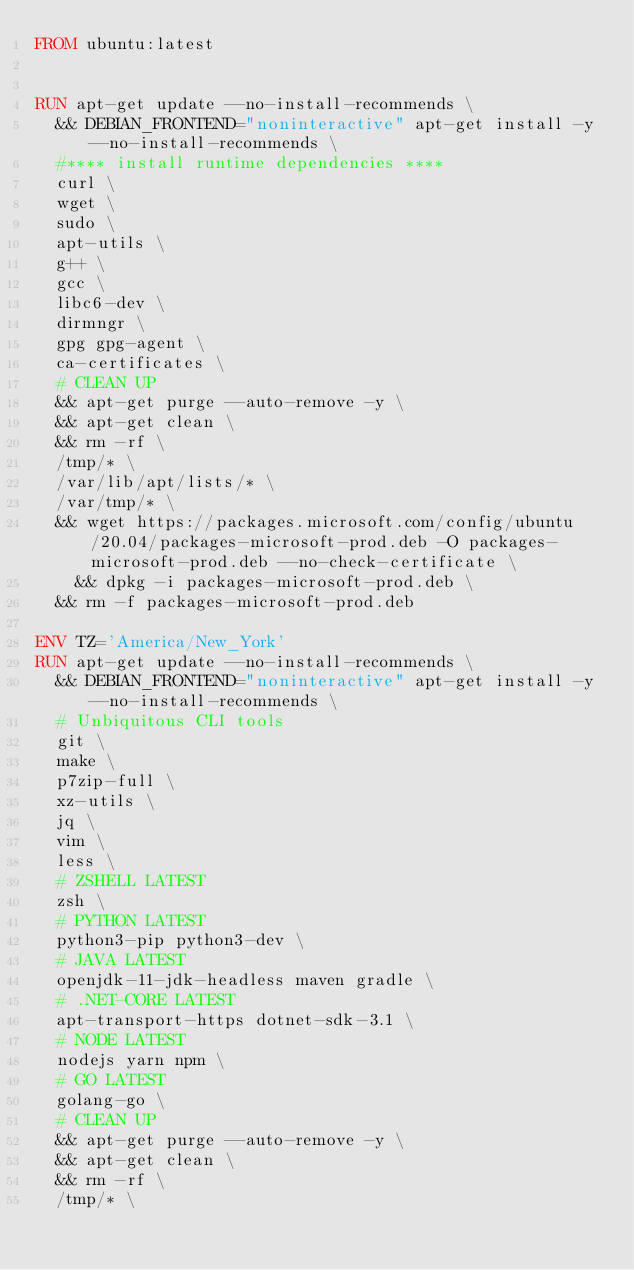<code> <loc_0><loc_0><loc_500><loc_500><_Dockerfile_>FROM ubuntu:latest


RUN apt-get update --no-install-recommends \
	&& DEBIAN_FRONTEND="noninteractive" apt-get install -y --no-install-recommends \
	#**** install runtime dependencies ****
	curl \
	wget \
	sudo \
	apt-utils \
	g++ \
	gcc \
	libc6-dev \
	dirmngr \
	gpg gpg-agent \
	ca-certificates \
	# CLEAN UP
 	&& apt-get purge --auto-remove -y \
	&& apt-get clean \
 	&& rm -rf \
	/tmp/* \
	/var/lib/apt/lists/* \
	/var/tmp/* \
	&& wget https://packages.microsoft.com/config/ubuntu/20.04/packages-microsoft-prod.deb -O packages-microsoft-prod.deb --no-check-certificate \
    && dpkg -i packages-microsoft-prod.deb \
	&& rm -f packages-microsoft-prod.deb

ENV TZ='America/New_York'
RUN apt-get update --no-install-recommends \
	&& DEBIAN_FRONTEND="noninteractive" apt-get install -y --no-install-recommends \
	# Unbiquitous CLI tools
	git \
	make \
	p7zip-full \
	xz-utils \
	jq \
	vim \
	less \
	# ZSHELL LATEST
	zsh \
	# PYTHON LATEST
	python3-pip python3-dev \
	# JAVA LATEST
	openjdk-11-jdk-headless maven gradle \
	# .NET-CORE LATEST
	apt-transport-https dotnet-sdk-3.1 \
	# NODE LATEST
	nodejs yarn npm \
	# GO LATEST
	golang-go \
	# CLEAN UP
 	&& apt-get purge --auto-remove -y \
	&& apt-get clean \
 	&& rm -rf \
	/tmp/* \</code> 